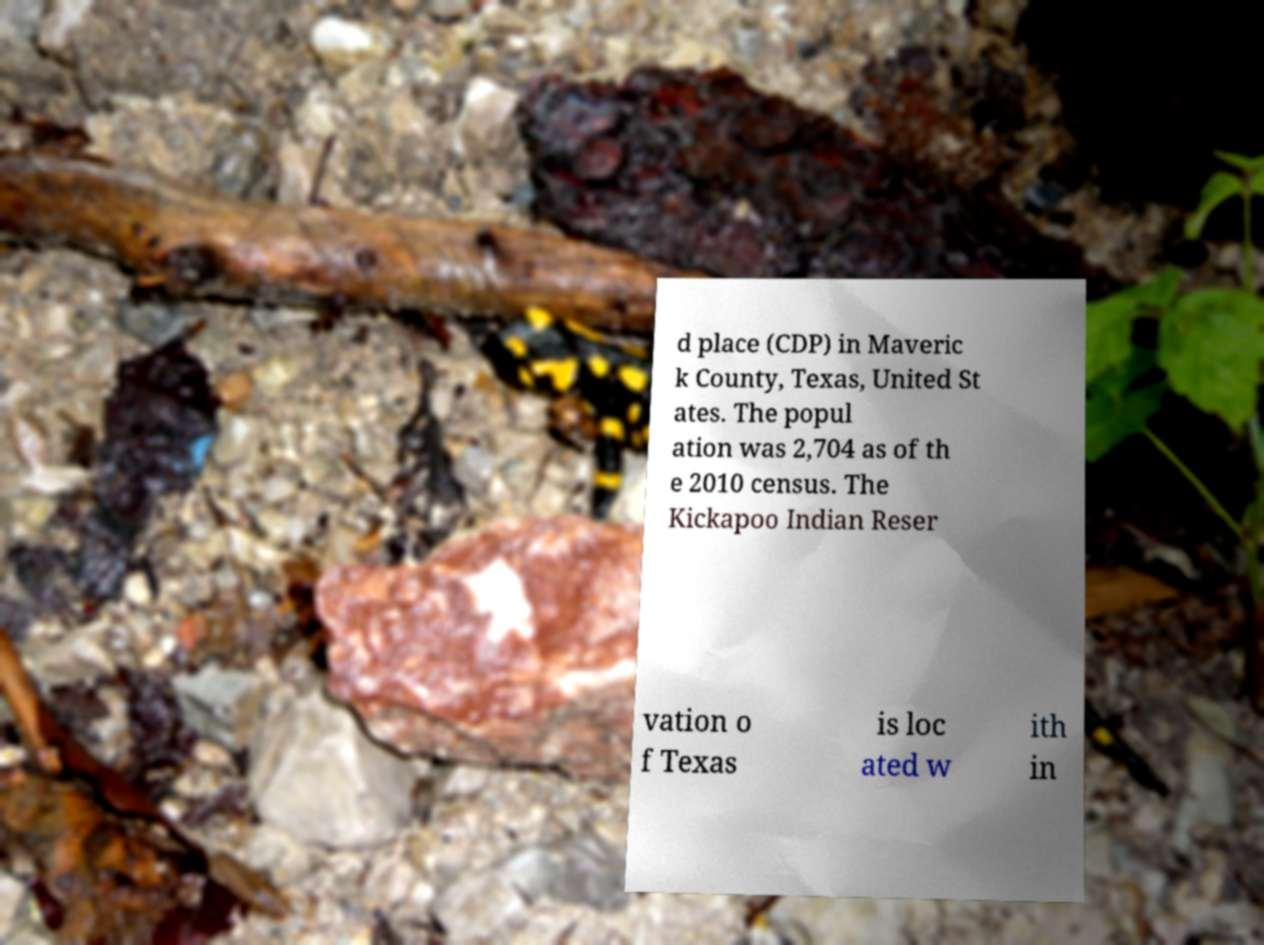Please read and relay the text visible in this image. What does it say? d place (CDP) in Maveric k County, Texas, United St ates. The popul ation was 2,704 as of th e 2010 census. The Kickapoo Indian Reser vation o f Texas is loc ated w ith in 